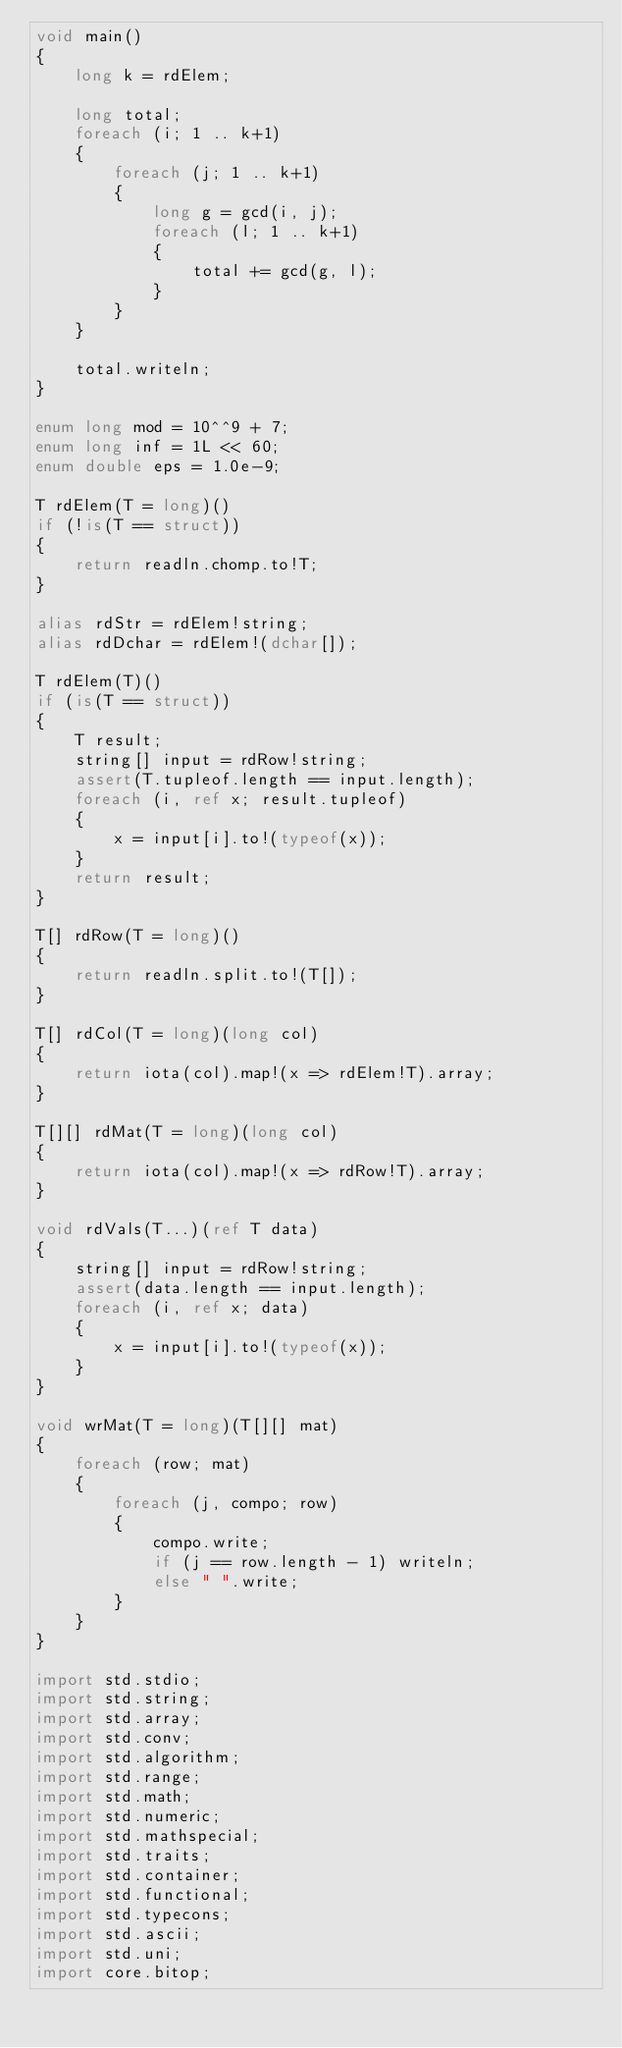<code> <loc_0><loc_0><loc_500><loc_500><_D_>void main()
{
    long k = rdElem;

    long total;
    foreach (i; 1 .. k+1)
    {
        foreach (j; 1 .. k+1)
        {
            long g = gcd(i, j);
            foreach (l; 1 .. k+1)
            {
                total += gcd(g, l);
            }
        }
    }

    total.writeln;
}

enum long mod = 10^^9 + 7;
enum long inf = 1L << 60;
enum double eps = 1.0e-9;

T rdElem(T = long)()
if (!is(T == struct))
{
    return readln.chomp.to!T;
}

alias rdStr = rdElem!string;
alias rdDchar = rdElem!(dchar[]);

T rdElem(T)()
if (is(T == struct))
{
    T result;
    string[] input = rdRow!string;
    assert(T.tupleof.length == input.length);
    foreach (i, ref x; result.tupleof)
    {
        x = input[i].to!(typeof(x));
    }
    return result;
}

T[] rdRow(T = long)()
{
    return readln.split.to!(T[]);
}

T[] rdCol(T = long)(long col)
{
    return iota(col).map!(x => rdElem!T).array;
}

T[][] rdMat(T = long)(long col)
{
    return iota(col).map!(x => rdRow!T).array;
}

void rdVals(T...)(ref T data)
{
    string[] input = rdRow!string;
    assert(data.length == input.length);
    foreach (i, ref x; data)
    {
        x = input[i].to!(typeof(x));
    }
}

void wrMat(T = long)(T[][] mat)
{
    foreach (row; mat)
    {
        foreach (j, compo; row)
        {
            compo.write;
            if (j == row.length - 1) writeln;
            else " ".write;
        }
    }
}

import std.stdio;
import std.string;
import std.array;
import std.conv;
import std.algorithm;
import std.range;
import std.math;
import std.numeric;
import std.mathspecial;
import std.traits;
import std.container;
import std.functional;
import std.typecons;
import std.ascii;
import std.uni;
import core.bitop;</code> 